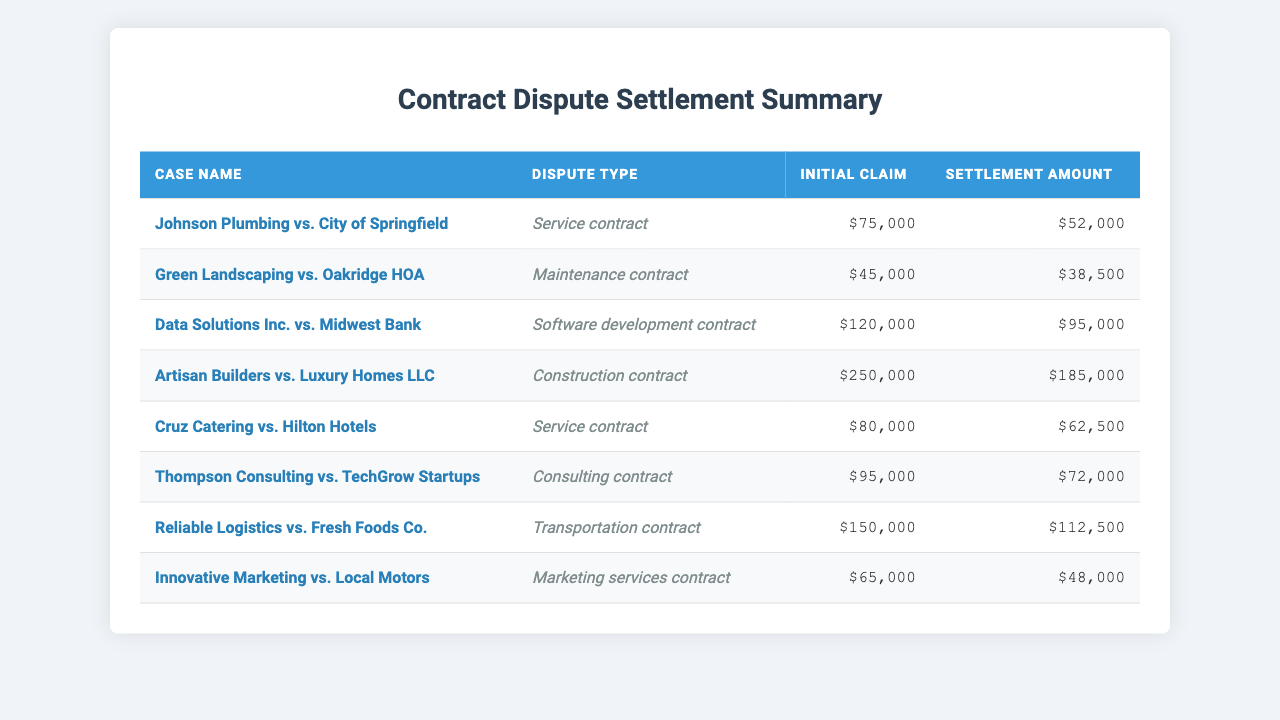What is the settlement amount for the case "Johnson Plumbing vs. City of Springfield"? The table lists "Johnson Plumbing vs. City of Springfield" under case names, and the corresponding settlement amount is indicated in the settlement amount column as $52,000.
Answer: $52,000 What was the initial claim made by "Cruz Catering vs. Hilton Hotels"? The table shows "Cruz Catering vs. Hilton Hotels" with an initial claim listed in the initial claim column as $80,000.
Answer: $80,000 Which case has the highest initial claim and what is the amount? By reviewing the initial claim amounts in the table, "Artisan Builders vs. Luxury Homes LLC" shows the highest claim at $250,000.
Answer: $250,000 What is the average settlement amount of all cases listed? The settlement amounts are $52,000, $38,500, $95,000, $185,000, $62,500, $72,000, $112,500, and $48,000. Summing these amounts gives $623,500, and dividing by the 8 cases results in an average of $77,937.50.
Answer: $77,937.50 How much more was the initial claim compared to the settlement for "Data Solutions Inc. vs. Midwest Bank"? The initial claim for this case is $120,000 and the settlement amount is $95,000. The difference is calculated by subtracting the settlement from the initial claim: $120,000 - $95,000 = $25,000.
Answer: $25,000 Is there a case that had a settlement amount lower than the initial claim of $70,000? By checking the settlement amounts, "Innovative Marketing vs. Local Motors" at $48,000 is lower than $70,000. Therefore, the statement is true.
Answer: Yes Which dispute type had the lowest settlement amount? After reviewing the settlement amounts by dispute type, "Green Landscaping vs. Oakridge HOA" has the lowest settlement amount of $38,500 under the maintenance contract dispute type.
Answer: Maintenance contract What is the total initial claim amount for all cases involving service contracts? For service contracts, the initial claims listed are $75,000 (Johnson Plumbing) and $80,000 (Cruz Catering). Adding these gives a total of $75,000 + $80,000 = $155,000.
Answer: $155,000 Are there more cases with a settlement amount above $70,000 or below $70,000? Analyzing the settlement amounts, four cases ($95,000, $185,000, $112,500, $72,000) are above $70,000, and four cases ($52,000, $38,500, $62,500, $48,000) are below $70,000. Thus, they are equal.
Answer: They are equal 